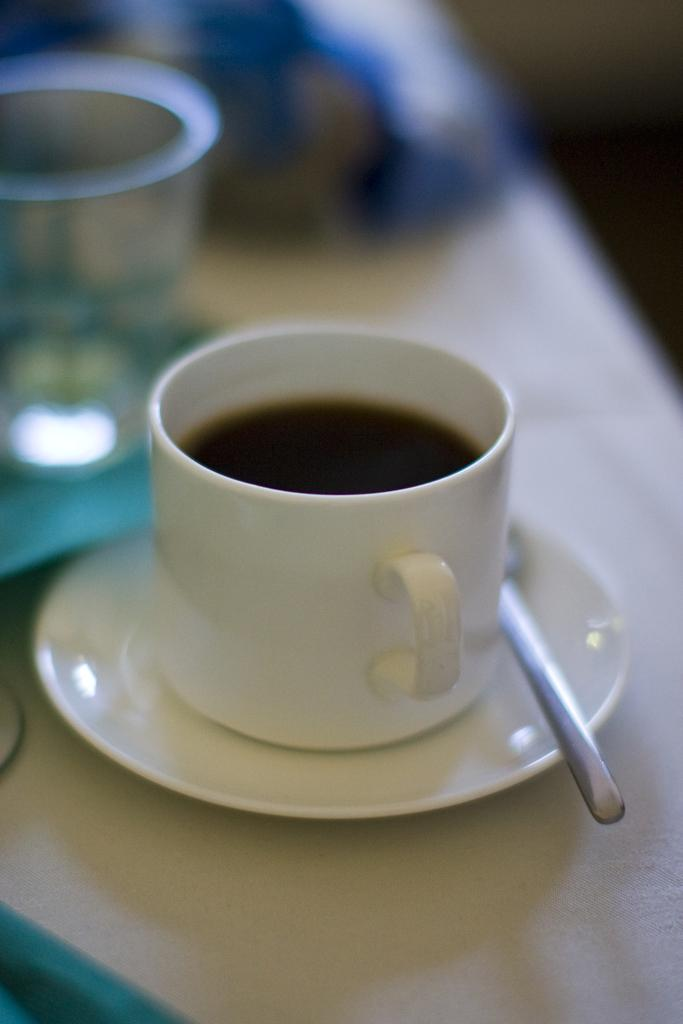What object is present on the saucer in the image? There is a spoon on the saucer in the image. What else is on the saucer besides the spoon? There is a cup with liquid on the saucer. What might be used to drink the liquid from the cup? The spoon could be used to stir or mix the liquid, but it is not the primary tool for drinking. What is visible behind the cup in the image? There are blurred things visible behind the cup. How does the group of people interact with the mist in the image? There is no group of people or mist present in the image. 